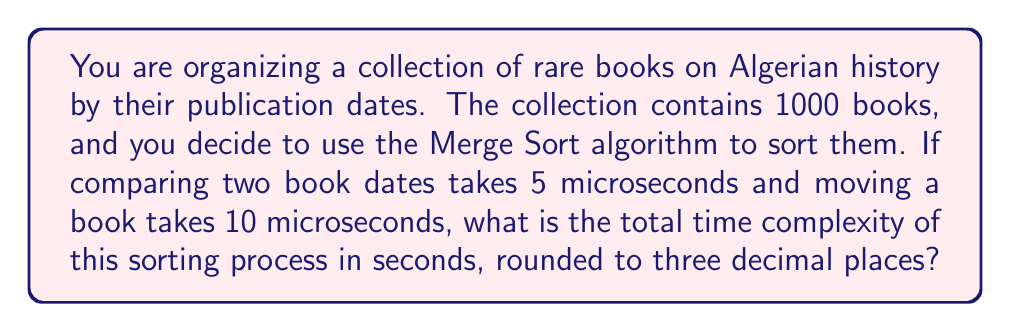Help me with this question. To solve this problem, we need to consider the time complexity of the Merge Sort algorithm and the given time constraints for comparisons and movements.

1. Merge Sort time complexity:
   - Comparisons: $O(n \log n)$
   - Movements: $O(n)$

2. Given information:
   - Number of books: $n = 1000$
   - Comparison time: 5 microseconds
   - Movement time: 10 microseconds

3. Calculate the number of comparisons:
   $$\text{Comparisons} = n \log_2 n = 1000 \log_2 1000 \approx 9966$$

4. Calculate the number of movements:
   $$\text{Movements} = n = 1000$$

5. Calculate total time:
   $$\begin{align*}
   \text{Total time} &= (\text{Comparisons} \times 5 \mu s) + (\text{Movements} \times 10 \mu s) \\
   &\approx (9966 \times 5) + (1000 \times 10) \\
   &\approx 49830 + 10000 \\
   &\approx 59830 \text{ microseconds}
   \end{align*}$$

6. Convert to seconds:
   $$\frac{59830 \text{ microseconds}}{1,000,000 \text{ microseconds/second}} \approx 0.05983 \text{ seconds}$$

7. Round to three decimal places:
   $$0.060 \text{ seconds}$$
Answer: 0.060 seconds 